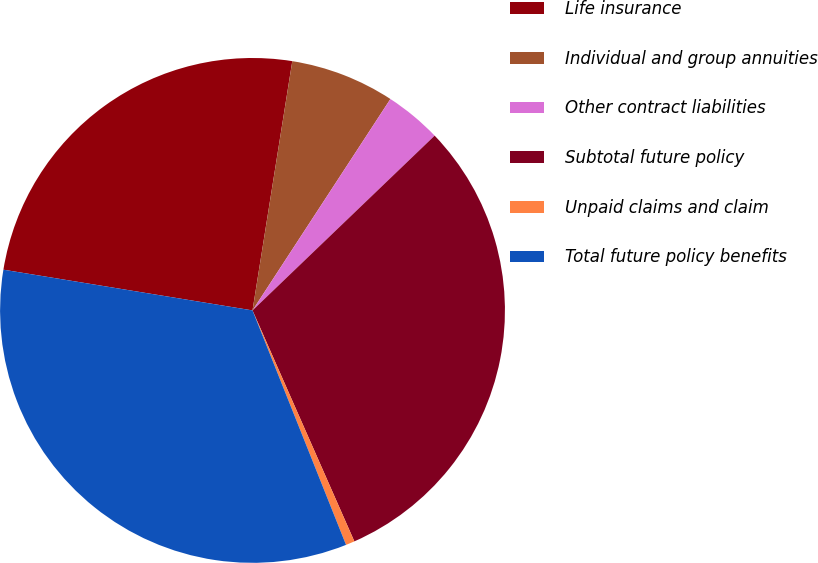<chart> <loc_0><loc_0><loc_500><loc_500><pie_chart><fcel>Life insurance<fcel>Individual and group annuities<fcel>Other contract liabilities<fcel>Subtotal future policy<fcel>Unpaid claims and claim<fcel>Total future policy benefits<nl><fcel>24.94%<fcel>6.68%<fcel>3.63%<fcel>30.56%<fcel>0.57%<fcel>33.62%<nl></chart> 